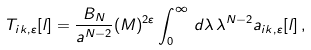<formula> <loc_0><loc_0><loc_500><loc_500>T _ { i k , \varepsilon } [ l ] = \frac { B _ { N } } { a ^ { N - 2 } } ( M ) ^ { 2 \varepsilon } \int _ { 0 } ^ { \infty } \, d \lambda \, \lambda ^ { N - 2 } a _ { i k , \varepsilon } [ l ] \, ,</formula> 